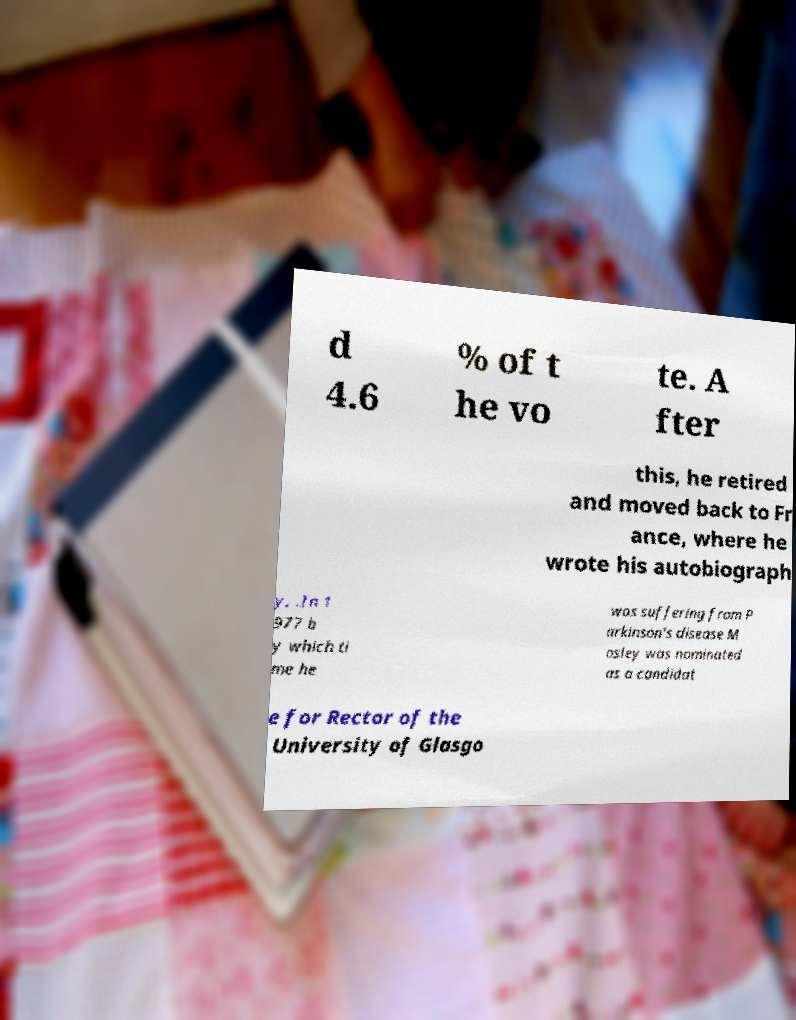For documentation purposes, I need the text within this image transcribed. Could you provide that? d 4.6 % of t he vo te. A fter this, he retired and moved back to Fr ance, where he wrote his autobiograph y, .In 1 977 b y which ti me he was suffering from P arkinson's disease M osley was nominated as a candidat e for Rector of the University of Glasgo 